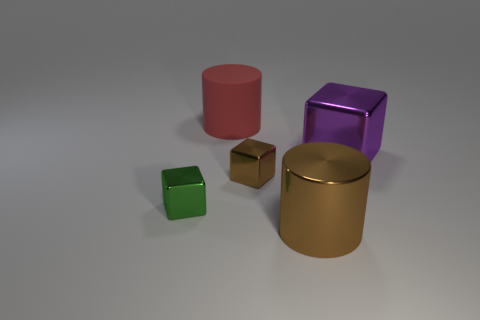Is there any other thing that is the same material as the red cylinder?
Provide a succinct answer. No. How many other things are the same color as the rubber thing?
Keep it short and to the point. 0. Are the big thing that is on the left side of the large brown shiny object and the large thing that is in front of the big purple object made of the same material?
Give a very brief answer. No. Are there an equal number of green metal cubes to the right of the large brown object and large purple metallic cubes behind the large red matte cylinder?
Keep it short and to the point. Yes. What material is the big cylinder right of the rubber object?
Make the answer very short. Metal. Is there anything else that is the same size as the shiny cylinder?
Your answer should be very brief. Yes. Are there fewer big rubber cubes than green metal blocks?
Your response must be concise. Yes. There is a shiny thing that is both behind the small green thing and to the left of the big shiny cylinder; what is its shape?
Keep it short and to the point. Cube. How many small green cubes are there?
Provide a succinct answer. 1. There is a cube left of the cylinder behind the tiny shiny block that is on the left side of the small brown metallic object; what is its material?
Offer a very short reply. Metal. 